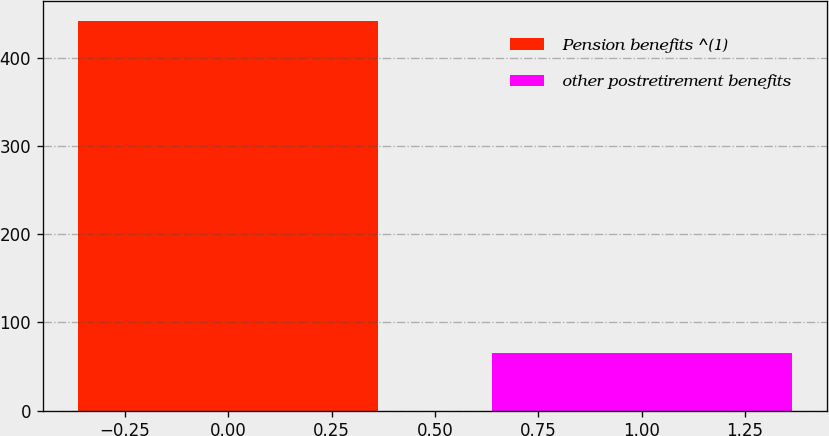Convert chart to OTSL. <chart><loc_0><loc_0><loc_500><loc_500><bar_chart><fcel>Pension benefits ^(1)<fcel>other postretirement benefits<nl><fcel>442.5<fcel>64.9<nl></chart> 